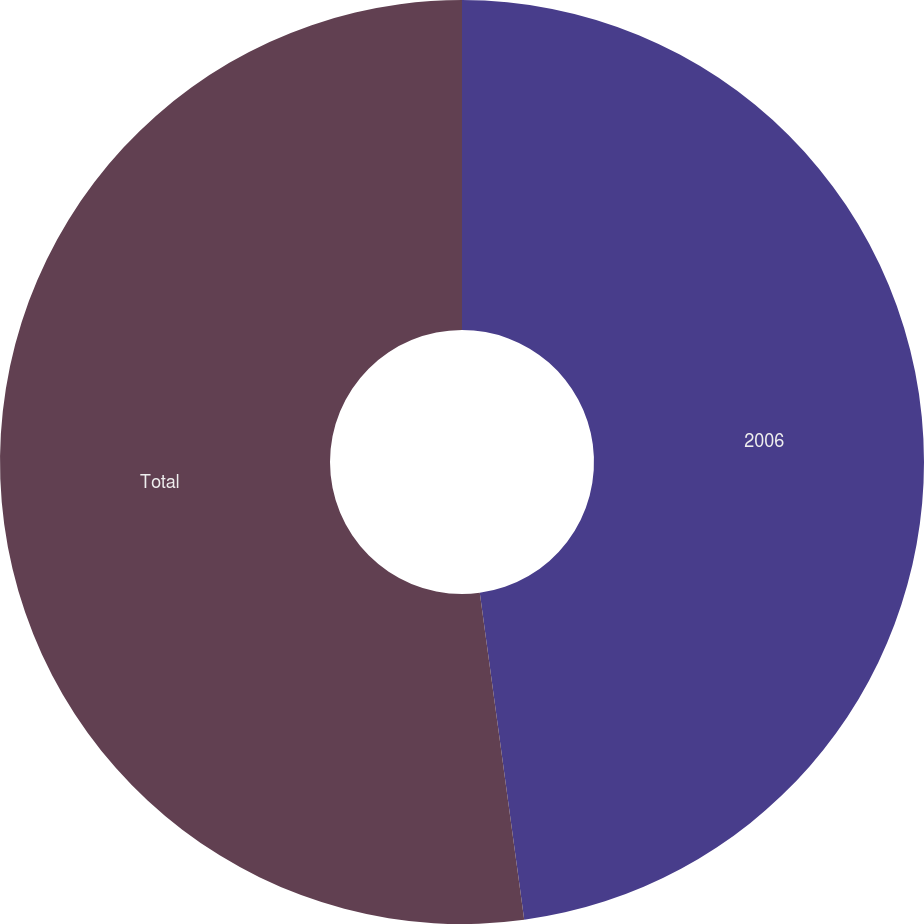<chart> <loc_0><loc_0><loc_500><loc_500><pie_chart><fcel>2006<fcel>Total<nl><fcel>47.85%<fcel>52.15%<nl></chart> 